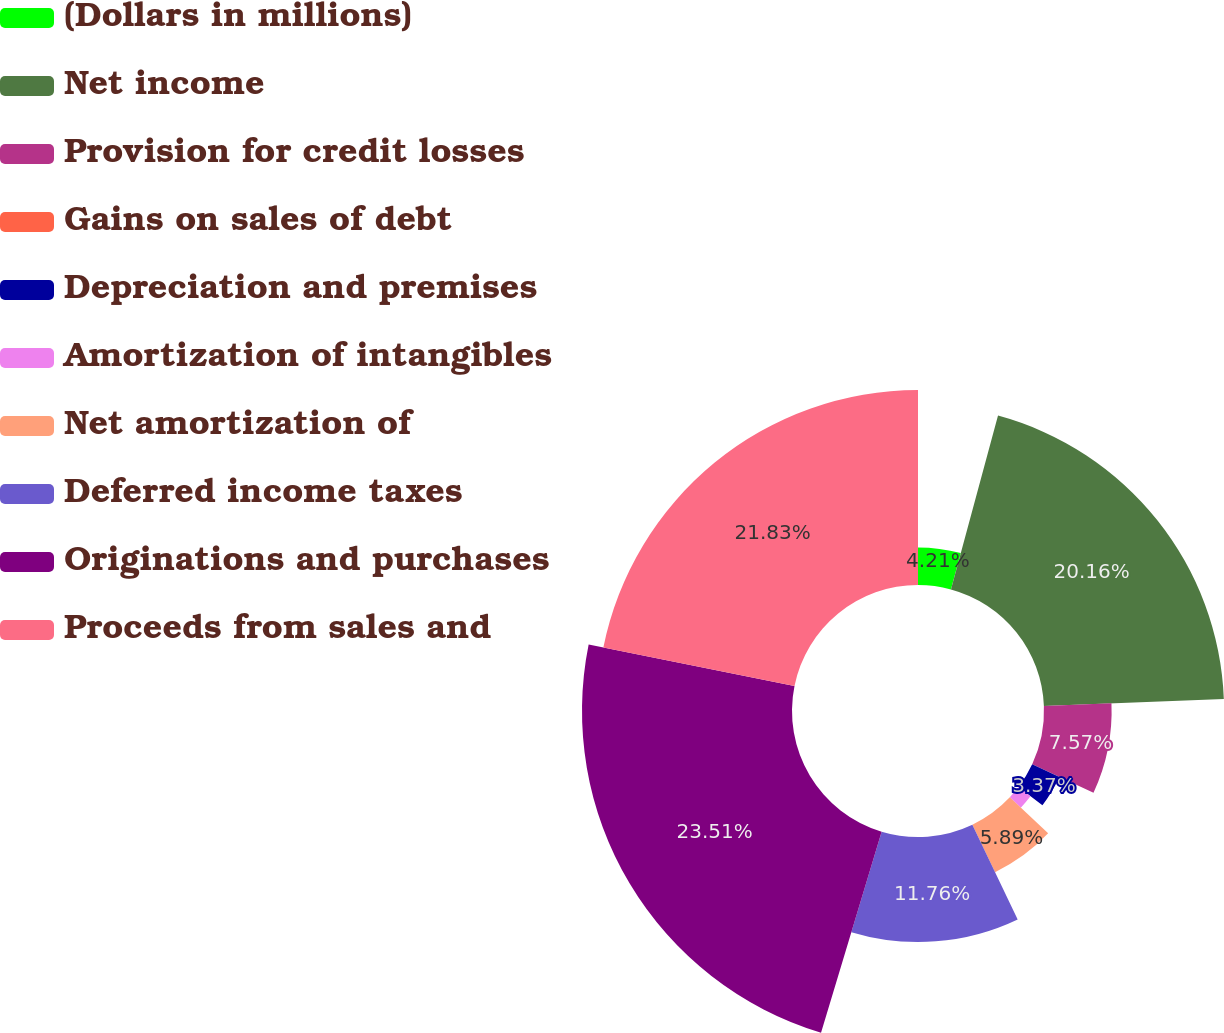Convert chart to OTSL. <chart><loc_0><loc_0><loc_500><loc_500><pie_chart><fcel>(Dollars in millions)<fcel>Net income<fcel>Provision for credit losses<fcel>Gains on sales of debt<fcel>Depreciation and premises<fcel>Amortization of intangibles<fcel>Net amortization of<fcel>Deferred income taxes<fcel>Originations and purchases<fcel>Proceeds from sales and<nl><fcel>4.21%<fcel>20.16%<fcel>7.57%<fcel>0.01%<fcel>3.37%<fcel>1.69%<fcel>5.89%<fcel>11.76%<fcel>23.51%<fcel>21.83%<nl></chart> 